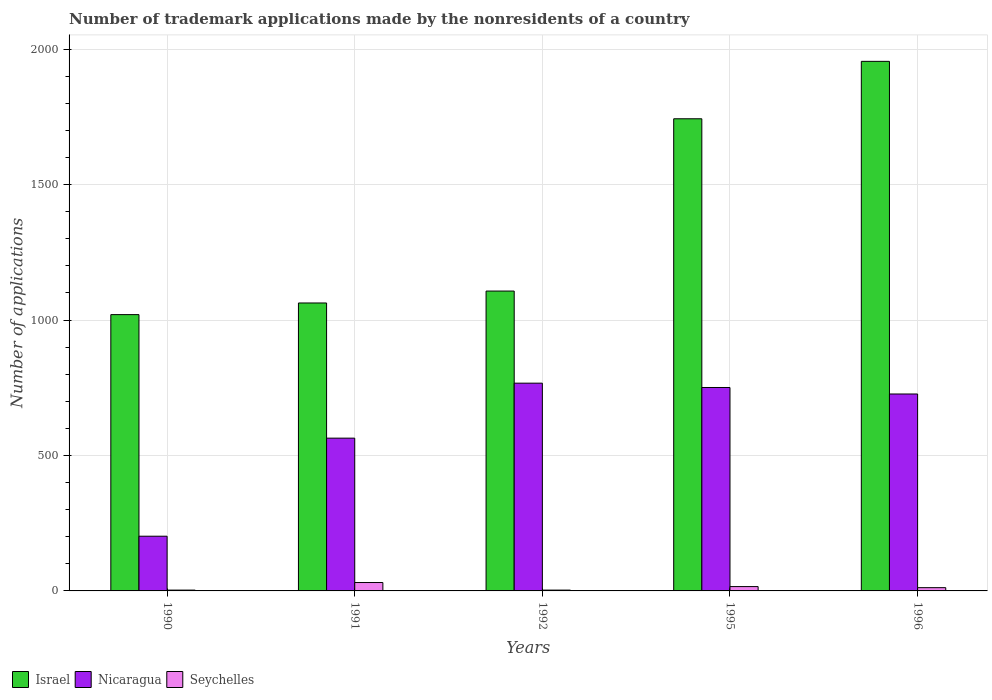How many different coloured bars are there?
Your answer should be very brief. 3. How many groups of bars are there?
Your response must be concise. 5. What is the label of the 3rd group of bars from the left?
Keep it short and to the point. 1992. What is the number of trademark applications made by the nonresidents in Israel in 1995?
Keep it short and to the point. 1743. Across all years, what is the minimum number of trademark applications made by the nonresidents in Israel?
Provide a succinct answer. 1020. What is the total number of trademark applications made by the nonresidents in Israel in the graph?
Keep it short and to the point. 6888. What is the difference between the number of trademark applications made by the nonresidents in Israel in 1991 and the number of trademark applications made by the nonresidents in Nicaragua in 1996?
Make the answer very short. 336. What is the average number of trademark applications made by the nonresidents in Nicaragua per year?
Your response must be concise. 602.2. In the year 1995, what is the difference between the number of trademark applications made by the nonresidents in Seychelles and number of trademark applications made by the nonresidents in Israel?
Your response must be concise. -1727. In how many years, is the number of trademark applications made by the nonresidents in Israel greater than 300?
Give a very brief answer. 5. What is the ratio of the number of trademark applications made by the nonresidents in Nicaragua in 1991 to that in 1996?
Ensure brevity in your answer.  0.78. Is the number of trademark applications made by the nonresidents in Israel in 1990 less than that in 1996?
Provide a short and direct response. Yes. What is the difference between the highest and the second highest number of trademark applications made by the nonresidents in Seychelles?
Provide a succinct answer. 15. What is the difference between the highest and the lowest number of trademark applications made by the nonresidents in Nicaragua?
Offer a terse response. 565. In how many years, is the number of trademark applications made by the nonresidents in Nicaragua greater than the average number of trademark applications made by the nonresidents in Nicaragua taken over all years?
Ensure brevity in your answer.  3. What does the 1st bar from the left in 1990 represents?
Your response must be concise. Israel. Is it the case that in every year, the sum of the number of trademark applications made by the nonresidents in Seychelles and number of trademark applications made by the nonresidents in Nicaragua is greater than the number of trademark applications made by the nonresidents in Israel?
Ensure brevity in your answer.  No. What is the difference between two consecutive major ticks on the Y-axis?
Provide a short and direct response. 500. Are the values on the major ticks of Y-axis written in scientific E-notation?
Offer a very short reply. No. Does the graph contain any zero values?
Provide a short and direct response. No. Does the graph contain grids?
Make the answer very short. Yes. How many legend labels are there?
Offer a terse response. 3. How are the legend labels stacked?
Your answer should be very brief. Horizontal. What is the title of the graph?
Make the answer very short. Number of trademark applications made by the nonresidents of a country. What is the label or title of the Y-axis?
Provide a short and direct response. Number of applications. What is the Number of applications in Israel in 1990?
Make the answer very short. 1020. What is the Number of applications in Nicaragua in 1990?
Give a very brief answer. 202. What is the Number of applications in Seychelles in 1990?
Your answer should be compact. 3. What is the Number of applications of Israel in 1991?
Keep it short and to the point. 1063. What is the Number of applications in Nicaragua in 1991?
Ensure brevity in your answer.  564. What is the Number of applications of Seychelles in 1991?
Offer a terse response. 31. What is the Number of applications in Israel in 1992?
Give a very brief answer. 1107. What is the Number of applications in Nicaragua in 1992?
Offer a terse response. 767. What is the Number of applications in Israel in 1995?
Ensure brevity in your answer.  1743. What is the Number of applications in Nicaragua in 1995?
Provide a short and direct response. 751. What is the Number of applications in Israel in 1996?
Your answer should be compact. 1955. What is the Number of applications of Nicaragua in 1996?
Your answer should be compact. 727. Across all years, what is the maximum Number of applications of Israel?
Your answer should be compact. 1955. Across all years, what is the maximum Number of applications of Nicaragua?
Your answer should be very brief. 767. Across all years, what is the maximum Number of applications in Seychelles?
Ensure brevity in your answer.  31. Across all years, what is the minimum Number of applications in Israel?
Provide a short and direct response. 1020. Across all years, what is the minimum Number of applications of Nicaragua?
Your answer should be compact. 202. Across all years, what is the minimum Number of applications of Seychelles?
Give a very brief answer. 3. What is the total Number of applications in Israel in the graph?
Ensure brevity in your answer.  6888. What is the total Number of applications in Nicaragua in the graph?
Keep it short and to the point. 3011. What is the difference between the Number of applications of Israel in 1990 and that in 1991?
Keep it short and to the point. -43. What is the difference between the Number of applications in Nicaragua in 1990 and that in 1991?
Keep it short and to the point. -362. What is the difference between the Number of applications in Israel in 1990 and that in 1992?
Offer a terse response. -87. What is the difference between the Number of applications in Nicaragua in 1990 and that in 1992?
Keep it short and to the point. -565. What is the difference between the Number of applications of Israel in 1990 and that in 1995?
Make the answer very short. -723. What is the difference between the Number of applications in Nicaragua in 1990 and that in 1995?
Offer a very short reply. -549. What is the difference between the Number of applications of Seychelles in 1990 and that in 1995?
Offer a very short reply. -13. What is the difference between the Number of applications of Israel in 1990 and that in 1996?
Your answer should be compact. -935. What is the difference between the Number of applications of Nicaragua in 1990 and that in 1996?
Provide a succinct answer. -525. What is the difference between the Number of applications of Seychelles in 1990 and that in 1996?
Keep it short and to the point. -9. What is the difference between the Number of applications in Israel in 1991 and that in 1992?
Give a very brief answer. -44. What is the difference between the Number of applications of Nicaragua in 1991 and that in 1992?
Keep it short and to the point. -203. What is the difference between the Number of applications in Seychelles in 1991 and that in 1992?
Ensure brevity in your answer.  28. What is the difference between the Number of applications in Israel in 1991 and that in 1995?
Provide a short and direct response. -680. What is the difference between the Number of applications of Nicaragua in 1991 and that in 1995?
Your answer should be compact. -187. What is the difference between the Number of applications of Israel in 1991 and that in 1996?
Make the answer very short. -892. What is the difference between the Number of applications in Nicaragua in 1991 and that in 1996?
Your response must be concise. -163. What is the difference between the Number of applications in Israel in 1992 and that in 1995?
Ensure brevity in your answer.  -636. What is the difference between the Number of applications in Nicaragua in 1992 and that in 1995?
Your answer should be compact. 16. What is the difference between the Number of applications in Seychelles in 1992 and that in 1995?
Your response must be concise. -13. What is the difference between the Number of applications in Israel in 1992 and that in 1996?
Provide a succinct answer. -848. What is the difference between the Number of applications of Israel in 1995 and that in 1996?
Keep it short and to the point. -212. What is the difference between the Number of applications of Seychelles in 1995 and that in 1996?
Keep it short and to the point. 4. What is the difference between the Number of applications in Israel in 1990 and the Number of applications in Nicaragua in 1991?
Ensure brevity in your answer.  456. What is the difference between the Number of applications of Israel in 1990 and the Number of applications of Seychelles in 1991?
Keep it short and to the point. 989. What is the difference between the Number of applications in Nicaragua in 1990 and the Number of applications in Seychelles in 1991?
Offer a very short reply. 171. What is the difference between the Number of applications of Israel in 1990 and the Number of applications of Nicaragua in 1992?
Ensure brevity in your answer.  253. What is the difference between the Number of applications of Israel in 1990 and the Number of applications of Seychelles in 1992?
Keep it short and to the point. 1017. What is the difference between the Number of applications in Nicaragua in 1990 and the Number of applications in Seychelles in 1992?
Offer a very short reply. 199. What is the difference between the Number of applications in Israel in 1990 and the Number of applications in Nicaragua in 1995?
Your answer should be very brief. 269. What is the difference between the Number of applications in Israel in 1990 and the Number of applications in Seychelles in 1995?
Provide a succinct answer. 1004. What is the difference between the Number of applications in Nicaragua in 1990 and the Number of applications in Seychelles in 1995?
Make the answer very short. 186. What is the difference between the Number of applications in Israel in 1990 and the Number of applications in Nicaragua in 1996?
Make the answer very short. 293. What is the difference between the Number of applications of Israel in 1990 and the Number of applications of Seychelles in 1996?
Ensure brevity in your answer.  1008. What is the difference between the Number of applications of Nicaragua in 1990 and the Number of applications of Seychelles in 1996?
Offer a very short reply. 190. What is the difference between the Number of applications in Israel in 1991 and the Number of applications in Nicaragua in 1992?
Your answer should be compact. 296. What is the difference between the Number of applications of Israel in 1991 and the Number of applications of Seychelles in 1992?
Your answer should be compact. 1060. What is the difference between the Number of applications in Nicaragua in 1991 and the Number of applications in Seychelles in 1992?
Your answer should be compact. 561. What is the difference between the Number of applications of Israel in 1991 and the Number of applications of Nicaragua in 1995?
Give a very brief answer. 312. What is the difference between the Number of applications in Israel in 1991 and the Number of applications in Seychelles in 1995?
Offer a very short reply. 1047. What is the difference between the Number of applications of Nicaragua in 1991 and the Number of applications of Seychelles in 1995?
Provide a short and direct response. 548. What is the difference between the Number of applications of Israel in 1991 and the Number of applications of Nicaragua in 1996?
Your answer should be compact. 336. What is the difference between the Number of applications in Israel in 1991 and the Number of applications in Seychelles in 1996?
Your answer should be very brief. 1051. What is the difference between the Number of applications in Nicaragua in 1991 and the Number of applications in Seychelles in 1996?
Your response must be concise. 552. What is the difference between the Number of applications in Israel in 1992 and the Number of applications in Nicaragua in 1995?
Offer a very short reply. 356. What is the difference between the Number of applications of Israel in 1992 and the Number of applications of Seychelles in 1995?
Offer a very short reply. 1091. What is the difference between the Number of applications in Nicaragua in 1992 and the Number of applications in Seychelles in 1995?
Keep it short and to the point. 751. What is the difference between the Number of applications in Israel in 1992 and the Number of applications in Nicaragua in 1996?
Offer a very short reply. 380. What is the difference between the Number of applications in Israel in 1992 and the Number of applications in Seychelles in 1996?
Keep it short and to the point. 1095. What is the difference between the Number of applications in Nicaragua in 1992 and the Number of applications in Seychelles in 1996?
Offer a very short reply. 755. What is the difference between the Number of applications in Israel in 1995 and the Number of applications in Nicaragua in 1996?
Your answer should be compact. 1016. What is the difference between the Number of applications in Israel in 1995 and the Number of applications in Seychelles in 1996?
Your response must be concise. 1731. What is the difference between the Number of applications of Nicaragua in 1995 and the Number of applications of Seychelles in 1996?
Make the answer very short. 739. What is the average Number of applications in Israel per year?
Ensure brevity in your answer.  1377.6. What is the average Number of applications of Nicaragua per year?
Keep it short and to the point. 602.2. In the year 1990, what is the difference between the Number of applications in Israel and Number of applications in Nicaragua?
Make the answer very short. 818. In the year 1990, what is the difference between the Number of applications in Israel and Number of applications in Seychelles?
Provide a short and direct response. 1017. In the year 1990, what is the difference between the Number of applications in Nicaragua and Number of applications in Seychelles?
Offer a very short reply. 199. In the year 1991, what is the difference between the Number of applications in Israel and Number of applications in Nicaragua?
Offer a terse response. 499. In the year 1991, what is the difference between the Number of applications in Israel and Number of applications in Seychelles?
Keep it short and to the point. 1032. In the year 1991, what is the difference between the Number of applications in Nicaragua and Number of applications in Seychelles?
Give a very brief answer. 533. In the year 1992, what is the difference between the Number of applications in Israel and Number of applications in Nicaragua?
Your response must be concise. 340. In the year 1992, what is the difference between the Number of applications of Israel and Number of applications of Seychelles?
Provide a short and direct response. 1104. In the year 1992, what is the difference between the Number of applications of Nicaragua and Number of applications of Seychelles?
Offer a terse response. 764. In the year 1995, what is the difference between the Number of applications in Israel and Number of applications in Nicaragua?
Provide a short and direct response. 992. In the year 1995, what is the difference between the Number of applications in Israel and Number of applications in Seychelles?
Provide a short and direct response. 1727. In the year 1995, what is the difference between the Number of applications in Nicaragua and Number of applications in Seychelles?
Make the answer very short. 735. In the year 1996, what is the difference between the Number of applications of Israel and Number of applications of Nicaragua?
Offer a very short reply. 1228. In the year 1996, what is the difference between the Number of applications of Israel and Number of applications of Seychelles?
Provide a short and direct response. 1943. In the year 1996, what is the difference between the Number of applications in Nicaragua and Number of applications in Seychelles?
Ensure brevity in your answer.  715. What is the ratio of the Number of applications of Israel in 1990 to that in 1991?
Offer a very short reply. 0.96. What is the ratio of the Number of applications in Nicaragua in 1990 to that in 1991?
Your answer should be compact. 0.36. What is the ratio of the Number of applications in Seychelles in 1990 to that in 1991?
Your answer should be compact. 0.1. What is the ratio of the Number of applications of Israel in 1990 to that in 1992?
Make the answer very short. 0.92. What is the ratio of the Number of applications of Nicaragua in 1990 to that in 1992?
Make the answer very short. 0.26. What is the ratio of the Number of applications of Seychelles in 1990 to that in 1992?
Your answer should be very brief. 1. What is the ratio of the Number of applications in Israel in 1990 to that in 1995?
Make the answer very short. 0.59. What is the ratio of the Number of applications of Nicaragua in 1990 to that in 1995?
Ensure brevity in your answer.  0.27. What is the ratio of the Number of applications of Seychelles in 1990 to that in 1995?
Ensure brevity in your answer.  0.19. What is the ratio of the Number of applications of Israel in 1990 to that in 1996?
Your answer should be compact. 0.52. What is the ratio of the Number of applications in Nicaragua in 1990 to that in 1996?
Keep it short and to the point. 0.28. What is the ratio of the Number of applications in Seychelles in 1990 to that in 1996?
Give a very brief answer. 0.25. What is the ratio of the Number of applications of Israel in 1991 to that in 1992?
Make the answer very short. 0.96. What is the ratio of the Number of applications of Nicaragua in 1991 to that in 1992?
Your response must be concise. 0.74. What is the ratio of the Number of applications in Seychelles in 1991 to that in 1992?
Ensure brevity in your answer.  10.33. What is the ratio of the Number of applications in Israel in 1991 to that in 1995?
Your answer should be very brief. 0.61. What is the ratio of the Number of applications in Nicaragua in 1991 to that in 1995?
Your answer should be compact. 0.75. What is the ratio of the Number of applications in Seychelles in 1991 to that in 1995?
Provide a short and direct response. 1.94. What is the ratio of the Number of applications in Israel in 1991 to that in 1996?
Your response must be concise. 0.54. What is the ratio of the Number of applications in Nicaragua in 1991 to that in 1996?
Keep it short and to the point. 0.78. What is the ratio of the Number of applications of Seychelles in 1991 to that in 1996?
Give a very brief answer. 2.58. What is the ratio of the Number of applications of Israel in 1992 to that in 1995?
Your answer should be compact. 0.64. What is the ratio of the Number of applications of Nicaragua in 1992 to that in 1995?
Keep it short and to the point. 1.02. What is the ratio of the Number of applications of Seychelles in 1992 to that in 1995?
Your response must be concise. 0.19. What is the ratio of the Number of applications of Israel in 1992 to that in 1996?
Provide a short and direct response. 0.57. What is the ratio of the Number of applications of Nicaragua in 1992 to that in 1996?
Offer a very short reply. 1.05. What is the ratio of the Number of applications of Seychelles in 1992 to that in 1996?
Keep it short and to the point. 0.25. What is the ratio of the Number of applications in Israel in 1995 to that in 1996?
Ensure brevity in your answer.  0.89. What is the ratio of the Number of applications in Nicaragua in 1995 to that in 1996?
Offer a terse response. 1.03. What is the difference between the highest and the second highest Number of applications of Israel?
Offer a very short reply. 212. What is the difference between the highest and the lowest Number of applications of Israel?
Keep it short and to the point. 935. What is the difference between the highest and the lowest Number of applications in Nicaragua?
Your answer should be compact. 565. 